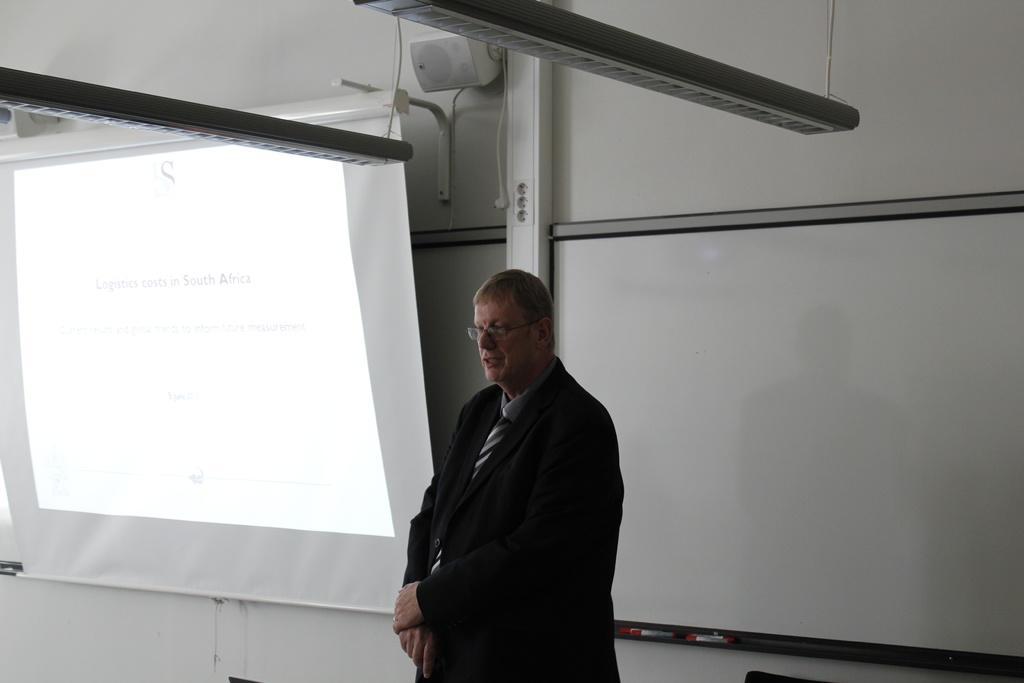Describe this image in one or two sentences. In the background we can see the wall, white object, stand, whiteboards, markers and a projector screen. At the top we can see the objects. In this picture we can see a man wearing spectacles, shirt, tie, blazer and it seems like he is talking. 